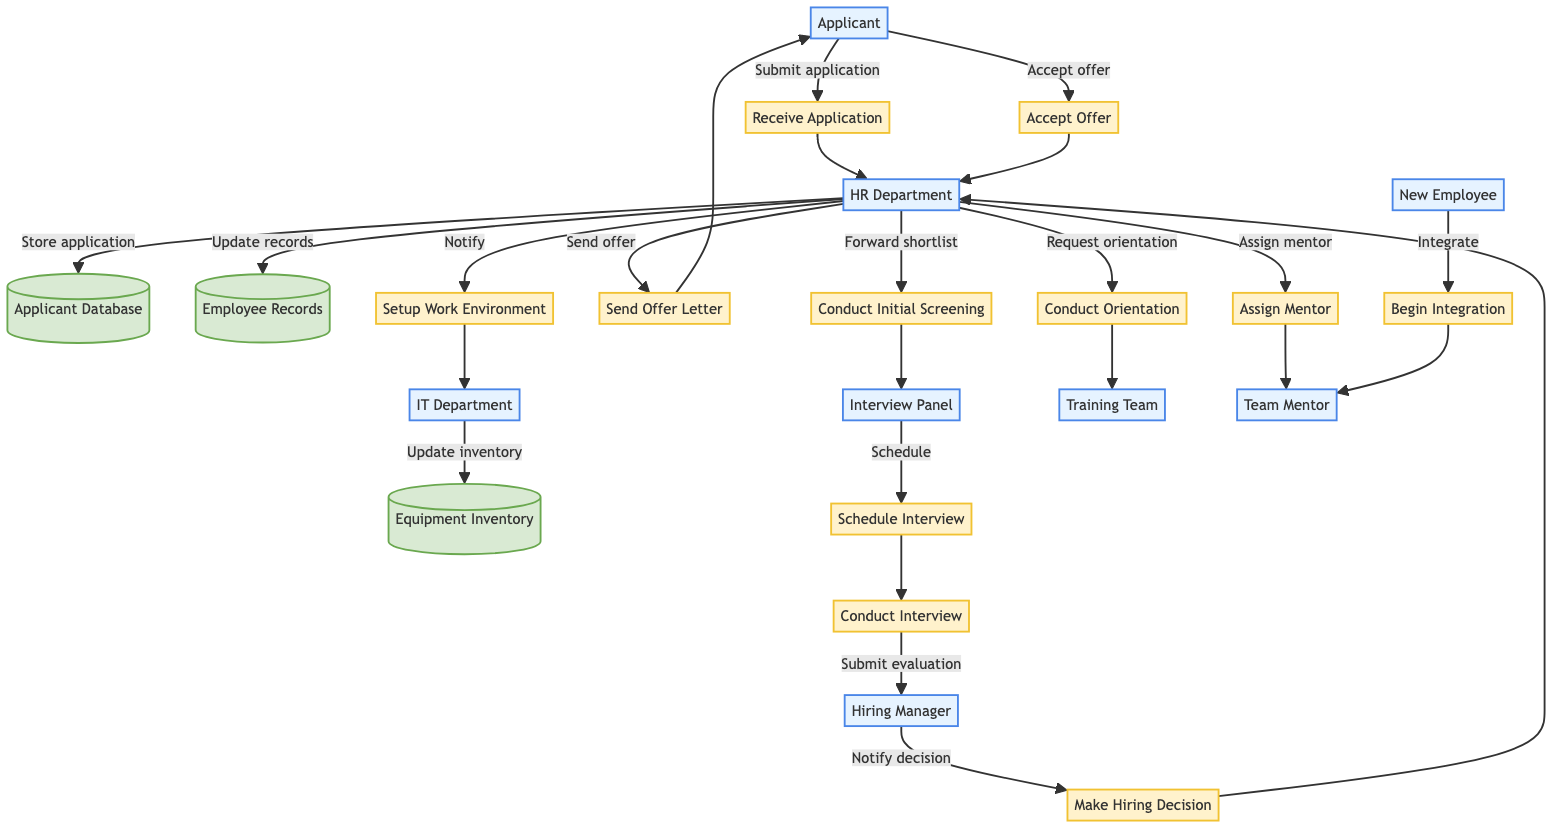What is the last step in the onboarding process? The last step in the onboarding process is "Begin Integration." This can be identified in the diagram as the terminal process where the new employee starts working with the help of a team mentor.
Answer: Begin Integration Which department is responsible for conducting interviews? The "Interview Panel" is responsible for conducting interviews. This is evident in the flow where the HR Department forwards shortlisted applications to this panel for evaluations.
Answer: Interview Panel How many entities are depicted in the diagram? By examining the diagram, we can count a total of eight entities involved in the onboarding process, which include Applicant, HR Department, Interview Panel, Hiring Manager, New Employee, IT Department, Training Team, and Team Mentor.
Answer: Eight What action follows the sending of the offer letter? The action that follows the sending of the offer letter is the applicant's acceptance of that offer. This sequence can be seen in the data flow from the HR Department to the Applicant, leading to the Applicant returning to HR Department to accept the offer.
Answer: Accept Offer Who updates the employee records after hiring? After the applicant is hired, the HR Department updates the employee records to include the details of the new employee. This action is indicated by the flow where HR updates the Employee Records after receiving the offer acceptance.
Answer: HR Department How many data stores are present in the diagram? The diagram shows that there are three data stores related to the onboarding process: Applicant Database, Employee Records, and Equipment Inventory. This can be counted directly from the diagram's datastore elements.
Answer: Three Which department is notified to set up the new employee's work environment? The IT Department is notified to set up the new employee's work environment. This is represented by the line indicating communication from the HR Department to the IT Department regarding the environment setup.
Answer: IT Department What does the Training Team provide to the new employee? The Training Team provides "Conduct Orientation" sessions. The flow illustrates that the HR Department requests the Training Team to conduct orientation for the new employee, emphasizing the role of this team in onboarding.
Answer: Conduct Orientation What role does the Team Mentor play in the onboarding process? The Team Mentor assists the new employee in integrating into the team and culture. This is demonstrated in the diagram by showing a flow from the new employee to the Team Mentor for support during integration.
Answer: Assists integration 